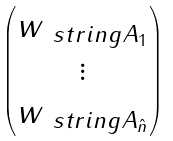Convert formula to latex. <formula><loc_0><loc_0><loc_500><loc_500>\begin{pmatrix} w _ { \ s t r i n g A _ { 1 } } \\ \vdots \\ w _ { \ s t r i n g A _ { \hat { n } } } \end{pmatrix}</formula> 